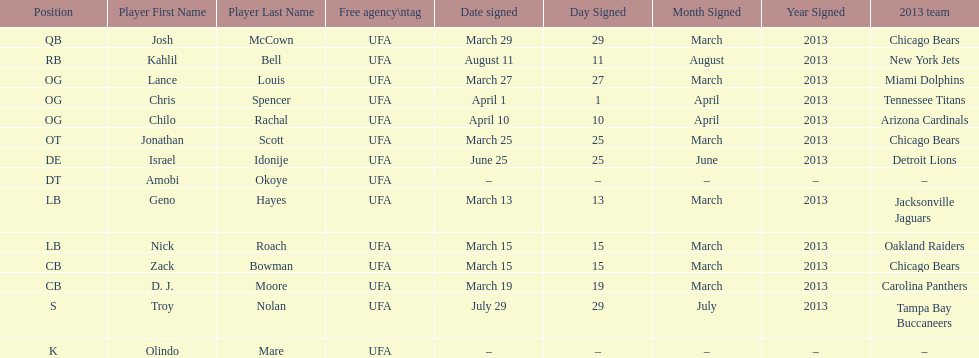The top played position according to this chart. OG. 